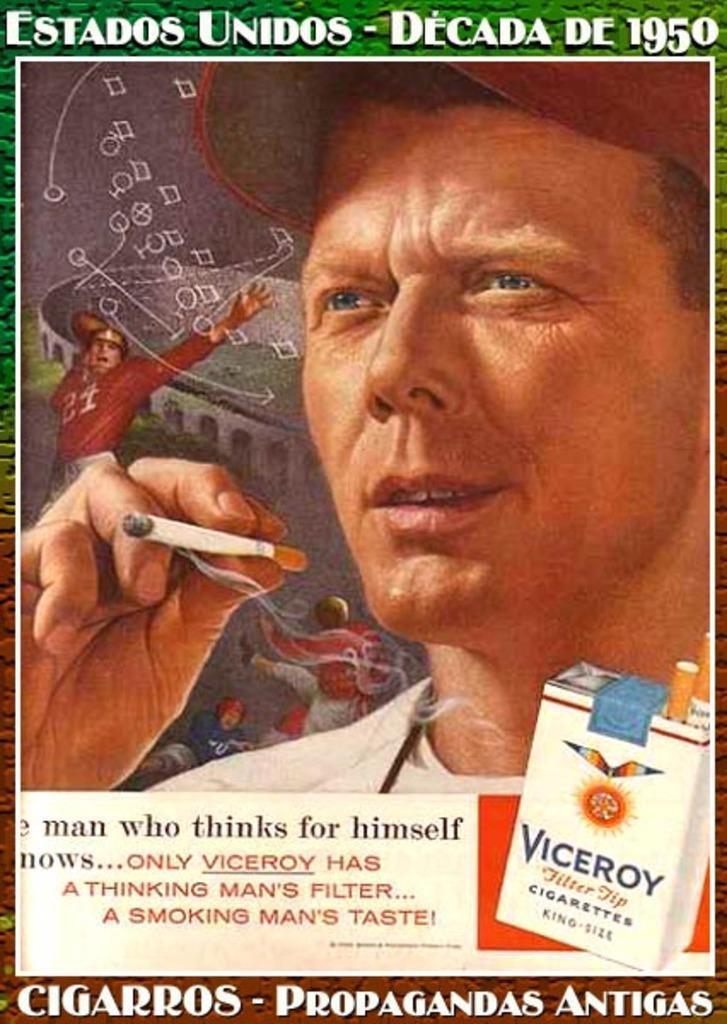How would you summarize this image in a sentence or two? In this image I can see a poster. There is a person, holding a cigarette. There is a cigarette box and some matter is written at the bottom. 